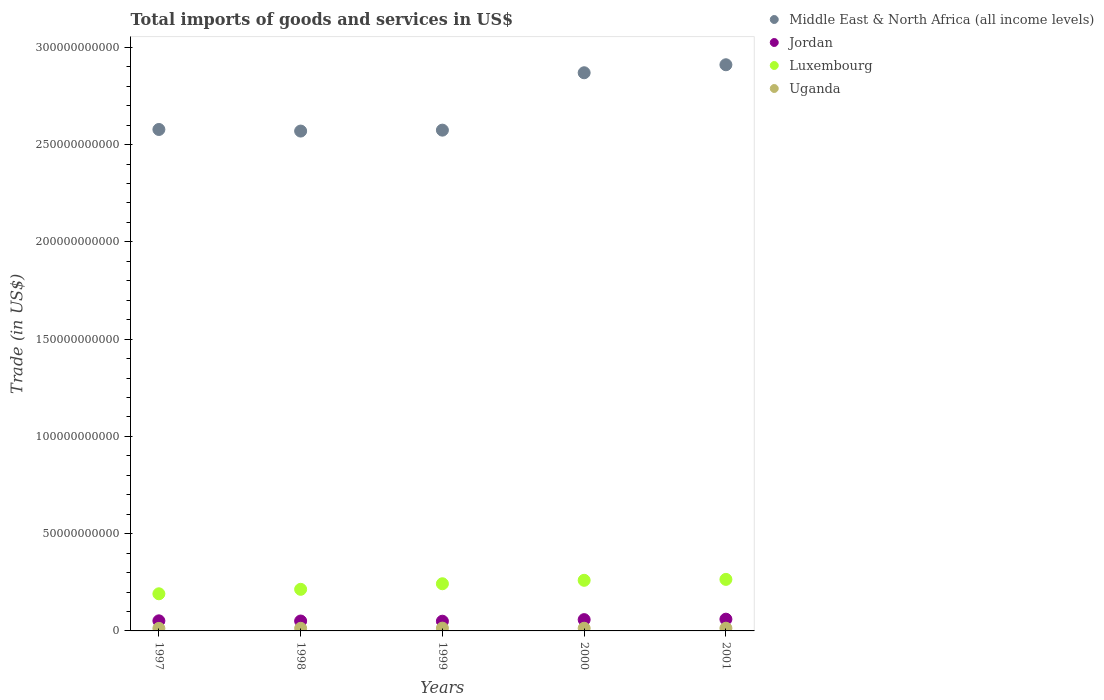What is the total imports of goods and services in Luxembourg in 1999?
Give a very brief answer. 2.42e+1. Across all years, what is the maximum total imports of goods and services in Middle East & North Africa (all income levels)?
Provide a succinct answer. 2.91e+11. Across all years, what is the minimum total imports of goods and services in Jordan?
Keep it short and to the point. 4.99e+09. In which year was the total imports of goods and services in Jordan maximum?
Provide a succinct answer. 2001. In which year was the total imports of goods and services in Jordan minimum?
Give a very brief answer. 1999. What is the total total imports of goods and services in Luxembourg in the graph?
Make the answer very short. 1.17e+11. What is the difference between the total imports of goods and services in Luxembourg in 1997 and that in 2001?
Provide a succinct answer. -7.41e+09. What is the difference between the total imports of goods and services in Middle East & North Africa (all income levels) in 1999 and the total imports of goods and services in Uganda in 2000?
Offer a very short reply. 2.56e+11. What is the average total imports of goods and services in Jordan per year?
Make the answer very short. 5.42e+09. In the year 1997, what is the difference between the total imports of goods and services in Middle East & North Africa (all income levels) and total imports of goods and services in Luxembourg?
Your answer should be very brief. 2.39e+11. In how many years, is the total imports of goods and services in Luxembourg greater than 60000000000 US$?
Your answer should be compact. 0. What is the ratio of the total imports of goods and services in Luxembourg in 1998 to that in 2000?
Ensure brevity in your answer.  0.82. Is the total imports of goods and services in Luxembourg in 1997 less than that in 2000?
Your answer should be very brief. Yes. Is the difference between the total imports of goods and services in Middle East & North Africa (all income levels) in 1997 and 2001 greater than the difference between the total imports of goods and services in Luxembourg in 1997 and 2001?
Make the answer very short. No. What is the difference between the highest and the second highest total imports of goods and services in Luxembourg?
Offer a terse response. 4.75e+08. What is the difference between the highest and the lowest total imports of goods and services in Middle East & North Africa (all income levels)?
Keep it short and to the point. 3.41e+1. In how many years, is the total imports of goods and services in Jordan greater than the average total imports of goods and services in Jordan taken over all years?
Keep it short and to the point. 2. Is it the case that in every year, the sum of the total imports of goods and services in Middle East & North Africa (all income levels) and total imports of goods and services in Luxembourg  is greater than the sum of total imports of goods and services in Jordan and total imports of goods and services in Uganda?
Offer a very short reply. Yes. Is it the case that in every year, the sum of the total imports of goods and services in Middle East & North Africa (all income levels) and total imports of goods and services in Luxembourg  is greater than the total imports of goods and services in Uganda?
Your response must be concise. Yes. Does the total imports of goods and services in Luxembourg monotonically increase over the years?
Provide a succinct answer. Yes. Is the total imports of goods and services in Luxembourg strictly less than the total imports of goods and services in Jordan over the years?
Your answer should be compact. No. How many dotlines are there?
Provide a short and direct response. 4. Does the graph contain any zero values?
Provide a succinct answer. No. Does the graph contain grids?
Your answer should be very brief. No. Where does the legend appear in the graph?
Give a very brief answer. Top right. How are the legend labels stacked?
Your answer should be compact. Vertical. What is the title of the graph?
Provide a succinct answer. Total imports of goods and services in US$. What is the label or title of the Y-axis?
Offer a terse response. Trade (in US$). What is the Trade (in US$) of Middle East & North Africa (all income levels) in 1997?
Make the answer very short. 2.58e+11. What is the Trade (in US$) in Jordan in 1997?
Make the answer very short. 5.19e+09. What is the Trade (in US$) of Luxembourg in 1997?
Give a very brief answer. 1.91e+1. What is the Trade (in US$) of Uganda in 1997?
Keep it short and to the point. 1.30e+09. What is the Trade (in US$) of Middle East & North Africa (all income levels) in 1998?
Your answer should be compact. 2.57e+11. What is the Trade (in US$) in Jordan in 1998?
Your answer should be compact. 5.09e+09. What is the Trade (in US$) of Luxembourg in 1998?
Your response must be concise. 2.14e+1. What is the Trade (in US$) of Uganda in 1998?
Offer a very short reply. 1.34e+09. What is the Trade (in US$) of Middle East & North Africa (all income levels) in 1999?
Provide a succinct answer. 2.57e+11. What is the Trade (in US$) in Jordan in 1999?
Give a very brief answer. 4.99e+09. What is the Trade (in US$) in Luxembourg in 1999?
Keep it short and to the point. 2.42e+1. What is the Trade (in US$) in Uganda in 1999?
Your response must be concise. 1.43e+09. What is the Trade (in US$) of Middle East & North Africa (all income levels) in 2000?
Give a very brief answer. 2.87e+11. What is the Trade (in US$) of Jordan in 2000?
Your answer should be compact. 5.80e+09. What is the Trade (in US$) of Luxembourg in 2000?
Give a very brief answer. 2.60e+1. What is the Trade (in US$) of Uganda in 2000?
Keep it short and to the point. 1.37e+09. What is the Trade (in US$) in Middle East & North Africa (all income levels) in 2001?
Ensure brevity in your answer.  2.91e+11. What is the Trade (in US$) of Jordan in 2001?
Your response must be concise. 6.03e+09. What is the Trade (in US$) in Luxembourg in 2001?
Provide a succinct answer. 2.65e+1. What is the Trade (in US$) of Uganda in 2001?
Offer a terse response. 1.39e+09. Across all years, what is the maximum Trade (in US$) of Middle East & North Africa (all income levels)?
Keep it short and to the point. 2.91e+11. Across all years, what is the maximum Trade (in US$) of Jordan?
Offer a very short reply. 6.03e+09. Across all years, what is the maximum Trade (in US$) in Luxembourg?
Your answer should be compact. 2.65e+1. Across all years, what is the maximum Trade (in US$) of Uganda?
Offer a terse response. 1.43e+09. Across all years, what is the minimum Trade (in US$) in Middle East & North Africa (all income levels)?
Make the answer very short. 2.57e+11. Across all years, what is the minimum Trade (in US$) of Jordan?
Your response must be concise. 4.99e+09. Across all years, what is the minimum Trade (in US$) in Luxembourg?
Provide a short and direct response. 1.91e+1. Across all years, what is the minimum Trade (in US$) in Uganda?
Your response must be concise. 1.30e+09. What is the total Trade (in US$) in Middle East & North Africa (all income levels) in the graph?
Provide a short and direct response. 1.35e+12. What is the total Trade (in US$) of Jordan in the graph?
Ensure brevity in your answer.  2.71e+1. What is the total Trade (in US$) of Luxembourg in the graph?
Provide a succinct answer. 1.17e+11. What is the total Trade (in US$) of Uganda in the graph?
Your answer should be compact. 6.83e+09. What is the difference between the Trade (in US$) of Middle East & North Africa (all income levels) in 1997 and that in 1998?
Make the answer very short. 8.19e+08. What is the difference between the Trade (in US$) in Jordan in 1997 and that in 1998?
Offer a very short reply. 9.59e+07. What is the difference between the Trade (in US$) in Luxembourg in 1997 and that in 1998?
Your answer should be very brief. -2.30e+09. What is the difference between the Trade (in US$) in Uganda in 1997 and that in 1998?
Your answer should be very brief. -3.97e+07. What is the difference between the Trade (in US$) of Middle East & North Africa (all income levels) in 1997 and that in 1999?
Offer a very short reply. 3.42e+08. What is the difference between the Trade (in US$) of Jordan in 1997 and that in 1999?
Your answer should be very brief. 1.96e+08. What is the difference between the Trade (in US$) in Luxembourg in 1997 and that in 1999?
Make the answer very short. -5.16e+09. What is the difference between the Trade (in US$) in Uganda in 1997 and that in 1999?
Offer a terse response. -1.22e+08. What is the difference between the Trade (in US$) of Middle East & North Africa (all income levels) in 1997 and that in 2000?
Keep it short and to the point. -2.92e+1. What is the difference between the Trade (in US$) of Jordan in 1997 and that in 2000?
Give a very brief answer. -6.16e+08. What is the difference between the Trade (in US$) in Luxembourg in 1997 and that in 2000?
Offer a very short reply. -6.93e+09. What is the difference between the Trade (in US$) in Uganda in 1997 and that in 2000?
Provide a short and direct response. -6.46e+07. What is the difference between the Trade (in US$) in Middle East & North Africa (all income levels) in 1997 and that in 2001?
Your answer should be compact. -3.33e+1. What is the difference between the Trade (in US$) in Jordan in 1997 and that in 2001?
Make the answer very short. -8.48e+08. What is the difference between the Trade (in US$) of Luxembourg in 1997 and that in 2001?
Provide a succinct answer. -7.41e+09. What is the difference between the Trade (in US$) of Uganda in 1997 and that in 2001?
Your response must be concise. -8.68e+07. What is the difference between the Trade (in US$) of Middle East & North Africa (all income levels) in 1998 and that in 1999?
Offer a terse response. -4.77e+08. What is the difference between the Trade (in US$) of Jordan in 1998 and that in 1999?
Provide a succinct answer. 9.99e+07. What is the difference between the Trade (in US$) in Luxembourg in 1998 and that in 1999?
Provide a succinct answer. -2.86e+09. What is the difference between the Trade (in US$) of Uganda in 1998 and that in 1999?
Give a very brief answer. -8.24e+07. What is the difference between the Trade (in US$) in Middle East & North Africa (all income levels) in 1998 and that in 2000?
Give a very brief answer. -3.00e+1. What is the difference between the Trade (in US$) of Jordan in 1998 and that in 2000?
Your response must be concise. -7.12e+08. What is the difference between the Trade (in US$) of Luxembourg in 1998 and that in 2000?
Offer a terse response. -4.63e+09. What is the difference between the Trade (in US$) of Uganda in 1998 and that in 2000?
Keep it short and to the point. -2.49e+07. What is the difference between the Trade (in US$) in Middle East & North Africa (all income levels) in 1998 and that in 2001?
Offer a terse response. -3.41e+1. What is the difference between the Trade (in US$) in Jordan in 1998 and that in 2001?
Provide a short and direct response. -9.44e+08. What is the difference between the Trade (in US$) in Luxembourg in 1998 and that in 2001?
Keep it short and to the point. -5.11e+09. What is the difference between the Trade (in US$) in Uganda in 1998 and that in 2001?
Provide a short and direct response. -4.71e+07. What is the difference between the Trade (in US$) of Middle East & North Africa (all income levels) in 1999 and that in 2000?
Keep it short and to the point. -2.95e+1. What is the difference between the Trade (in US$) of Jordan in 1999 and that in 2000?
Your answer should be compact. -8.12e+08. What is the difference between the Trade (in US$) of Luxembourg in 1999 and that in 2000?
Provide a short and direct response. -1.77e+09. What is the difference between the Trade (in US$) of Uganda in 1999 and that in 2000?
Offer a terse response. 5.75e+07. What is the difference between the Trade (in US$) of Middle East & North Africa (all income levels) in 1999 and that in 2001?
Your response must be concise. -3.36e+1. What is the difference between the Trade (in US$) in Jordan in 1999 and that in 2001?
Give a very brief answer. -1.04e+09. What is the difference between the Trade (in US$) in Luxembourg in 1999 and that in 2001?
Offer a very short reply. -2.24e+09. What is the difference between the Trade (in US$) in Uganda in 1999 and that in 2001?
Keep it short and to the point. 3.53e+07. What is the difference between the Trade (in US$) of Middle East & North Africa (all income levels) in 2000 and that in 2001?
Offer a terse response. -4.11e+09. What is the difference between the Trade (in US$) in Jordan in 2000 and that in 2001?
Your answer should be very brief. -2.32e+08. What is the difference between the Trade (in US$) in Luxembourg in 2000 and that in 2001?
Keep it short and to the point. -4.75e+08. What is the difference between the Trade (in US$) in Uganda in 2000 and that in 2001?
Provide a short and direct response. -2.22e+07. What is the difference between the Trade (in US$) of Middle East & North Africa (all income levels) in 1997 and the Trade (in US$) of Jordan in 1998?
Provide a succinct answer. 2.53e+11. What is the difference between the Trade (in US$) in Middle East & North Africa (all income levels) in 1997 and the Trade (in US$) in Luxembourg in 1998?
Offer a very short reply. 2.36e+11. What is the difference between the Trade (in US$) in Middle East & North Africa (all income levels) in 1997 and the Trade (in US$) in Uganda in 1998?
Your answer should be very brief. 2.56e+11. What is the difference between the Trade (in US$) in Jordan in 1997 and the Trade (in US$) in Luxembourg in 1998?
Provide a succinct answer. -1.62e+1. What is the difference between the Trade (in US$) in Jordan in 1997 and the Trade (in US$) in Uganda in 1998?
Offer a very short reply. 3.84e+09. What is the difference between the Trade (in US$) in Luxembourg in 1997 and the Trade (in US$) in Uganda in 1998?
Offer a very short reply. 1.77e+1. What is the difference between the Trade (in US$) in Middle East & North Africa (all income levels) in 1997 and the Trade (in US$) in Jordan in 1999?
Provide a short and direct response. 2.53e+11. What is the difference between the Trade (in US$) of Middle East & North Africa (all income levels) in 1997 and the Trade (in US$) of Luxembourg in 1999?
Provide a succinct answer. 2.34e+11. What is the difference between the Trade (in US$) of Middle East & North Africa (all income levels) in 1997 and the Trade (in US$) of Uganda in 1999?
Your answer should be very brief. 2.56e+11. What is the difference between the Trade (in US$) of Jordan in 1997 and the Trade (in US$) of Luxembourg in 1999?
Offer a terse response. -1.91e+1. What is the difference between the Trade (in US$) of Jordan in 1997 and the Trade (in US$) of Uganda in 1999?
Your answer should be compact. 3.76e+09. What is the difference between the Trade (in US$) in Luxembourg in 1997 and the Trade (in US$) in Uganda in 1999?
Offer a very short reply. 1.77e+1. What is the difference between the Trade (in US$) of Middle East & North Africa (all income levels) in 1997 and the Trade (in US$) of Jordan in 2000?
Offer a terse response. 2.52e+11. What is the difference between the Trade (in US$) of Middle East & North Africa (all income levels) in 1997 and the Trade (in US$) of Luxembourg in 2000?
Offer a very short reply. 2.32e+11. What is the difference between the Trade (in US$) in Middle East & North Africa (all income levels) in 1997 and the Trade (in US$) in Uganda in 2000?
Your answer should be very brief. 2.56e+11. What is the difference between the Trade (in US$) in Jordan in 1997 and the Trade (in US$) in Luxembourg in 2000?
Your answer should be compact. -2.08e+1. What is the difference between the Trade (in US$) in Jordan in 1997 and the Trade (in US$) in Uganda in 2000?
Provide a short and direct response. 3.82e+09. What is the difference between the Trade (in US$) of Luxembourg in 1997 and the Trade (in US$) of Uganda in 2000?
Keep it short and to the point. 1.77e+1. What is the difference between the Trade (in US$) in Middle East & North Africa (all income levels) in 1997 and the Trade (in US$) in Jordan in 2001?
Offer a very short reply. 2.52e+11. What is the difference between the Trade (in US$) in Middle East & North Africa (all income levels) in 1997 and the Trade (in US$) in Luxembourg in 2001?
Give a very brief answer. 2.31e+11. What is the difference between the Trade (in US$) of Middle East & North Africa (all income levels) in 1997 and the Trade (in US$) of Uganda in 2001?
Provide a short and direct response. 2.56e+11. What is the difference between the Trade (in US$) of Jordan in 1997 and the Trade (in US$) of Luxembourg in 2001?
Your response must be concise. -2.13e+1. What is the difference between the Trade (in US$) in Jordan in 1997 and the Trade (in US$) in Uganda in 2001?
Your answer should be very brief. 3.80e+09. What is the difference between the Trade (in US$) of Luxembourg in 1997 and the Trade (in US$) of Uganda in 2001?
Ensure brevity in your answer.  1.77e+1. What is the difference between the Trade (in US$) in Middle East & North Africa (all income levels) in 1998 and the Trade (in US$) in Jordan in 1999?
Offer a terse response. 2.52e+11. What is the difference between the Trade (in US$) of Middle East & North Africa (all income levels) in 1998 and the Trade (in US$) of Luxembourg in 1999?
Provide a short and direct response. 2.33e+11. What is the difference between the Trade (in US$) in Middle East & North Africa (all income levels) in 1998 and the Trade (in US$) in Uganda in 1999?
Make the answer very short. 2.56e+11. What is the difference between the Trade (in US$) in Jordan in 1998 and the Trade (in US$) in Luxembourg in 1999?
Offer a very short reply. -1.92e+1. What is the difference between the Trade (in US$) of Jordan in 1998 and the Trade (in US$) of Uganda in 1999?
Keep it short and to the point. 3.66e+09. What is the difference between the Trade (in US$) of Luxembourg in 1998 and the Trade (in US$) of Uganda in 1999?
Ensure brevity in your answer.  2.00e+1. What is the difference between the Trade (in US$) of Middle East & North Africa (all income levels) in 1998 and the Trade (in US$) of Jordan in 2000?
Offer a terse response. 2.51e+11. What is the difference between the Trade (in US$) in Middle East & North Africa (all income levels) in 1998 and the Trade (in US$) in Luxembourg in 2000?
Make the answer very short. 2.31e+11. What is the difference between the Trade (in US$) in Middle East & North Africa (all income levels) in 1998 and the Trade (in US$) in Uganda in 2000?
Your answer should be very brief. 2.56e+11. What is the difference between the Trade (in US$) of Jordan in 1998 and the Trade (in US$) of Luxembourg in 2000?
Your response must be concise. -2.09e+1. What is the difference between the Trade (in US$) in Jordan in 1998 and the Trade (in US$) in Uganda in 2000?
Your answer should be very brief. 3.72e+09. What is the difference between the Trade (in US$) of Luxembourg in 1998 and the Trade (in US$) of Uganda in 2000?
Provide a short and direct response. 2.00e+1. What is the difference between the Trade (in US$) in Middle East & North Africa (all income levels) in 1998 and the Trade (in US$) in Jordan in 2001?
Make the answer very short. 2.51e+11. What is the difference between the Trade (in US$) of Middle East & North Africa (all income levels) in 1998 and the Trade (in US$) of Luxembourg in 2001?
Give a very brief answer. 2.30e+11. What is the difference between the Trade (in US$) of Middle East & North Africa (all income levels) in 1998 and the Trade (in US$) of Uganda in 2001?
Provide a succinct answer. 2.56e+11. What is the difference between the Trade (in US$) of Jordan in 1998 and the Trade (in US$) of Luxembourg in 2001?
Give a very brief answer. -2.14e+1. What is the difference between the Trade (in US$) in Jordan in 1998 and the Trade (in US$) in Uganda in 2001?
Give a very brief answer. 3.70e+09. What is the difference between the Trade (in US$) of Luxembourg in 1998 and the Trade (in US$) of Uganda in 2001?
Offer a very short reply. 2.00e+1. What is the difference between the Trade (in US$) of Middle East & North Africa (all income levels) in 1999 and the Trade (in US$) of Jordan in 2000?
Give a very brief answer. 2.52e+11. What is the difference between the Trade (in US$) in Middle East & North Africa (all income levels) in 1999 and the Trade (in US$) in Luxembourg in 2000?
Give a very brief answer. 2.31e+11. What is the difference between the Trade (in US$) in Middle East & North Africa (all income levels) in 1999 and the Trade (in US$) in Uganda in 2000?
Give a very brief answer. 2.56e+11. What is the difference between the Trade (in US$) of Jordan in 1999 and the Trade (in US$) of Luxembourg in 2000?
Ensure brevity in your answer.  -2.10e+1. What is the difference between the Trade (in US$) in Jordan in 1999 and the Trade (in US$) in Uganda in 2000?
Make the answer very short. 3.62e+09. What is the difference between the Trade (in US$) in Luxembourg in 1999 and the Trade (in US$) in Uganda in 2000?
Make the answer very short. 2.29e+1. What is the difference between the Trade (in US$) in Middle East & North Africa (all income levels) in 1999 and the Trade (in US$) in Jordan in 2001?
Make the answer very short. 2.51e+11. What is the difference between the Trade (in US$) in Middle East & North Africa (all income levels) in 1999 and the Trade (in US$) in Luxembourg in 2001?
Your response must be concise. 2.31e+11. What is the difference between the Trade (in US$) of Middle East & North Africa (all income levels) in 1999 and the Trade (in US$) of Uganda in 2001?
Offer a terse response. 2.56e+11. What is the difference between the Trade (in US$) in Jordan in 1999 and the Trade (in US$) in Luxembourg in 2001?
Offer a terse response. -2.15e+1. What is the difference between the Trade (in US$) in Jordan in 1999 and the Trade (in US$) in Uganda in 2001?
Give a very brief answer. 3.60e+09. What is the difference between the Trade (in US$) of Luxembourg in 1999 and the Trade (in US$) of Uganda in 2001?
Give a very brief answer. 2.29e+1. What is the difference between the Trade (in US$) of Middle East & North Africa (all income levels) in 2000 and the Trade (in US$) of Jordan in 2001?
Your response must be concise. 2.81e+11. What is the difference between the Trade (in US$) in Middle East & North Africa (all income levels) in 2000 and the Trade (in US$) in Luxembourg in 2001?
Your response must be concise. 2.60e+11. What is the difference between the Trade (in US$) of Middle East & North Africa (all income levels) in 2000 and the Trade (in US$) of Uganda in 2001?
Offer a terse response. 2.86e+11. What is the difference between the Trade (in US$) of Jordan in 2000 and the Trade (in US$) of Luxembourg in 2001?
Your answer should be very brief. -2.07e+1. What is the difference between the Trade (in US$) of Jordan in 2000 and the Trade (in US$) of Uganda in 2001?
Your answer should be very brief. 4.41e+09. What is the difference between the Trade (in US$) in Luxembourg in 2000 and the Trade (in US$) in Uganda in 2001?
Ensure brevity in your answer.  2.46e+1. What is the average Trade (in US$) of Middle East & North Africa (all income levels) per year?
Your answer should be compact. 2.70e+11. What is the average Trade (in US$) of Jordan per year?
Ensure brevity in your answer.  5.42e+09. What is the average Trade (in US$) in Luxembourg per year?
Provide a short and direct response. 2.34e+1. What is the average Trade (in US$) of Uganda per year?
Give a very brief answer. 1.37e+09. In the year 1997, what is the difference between the Trade (in US$) of Middle East & North Africa (all income levels) and Trade (in US$) of Jordan?
Offer a very short reply. 2.53e+11. In the year 1997, what is the difference between the Trade (in US$) in Middle East & North Africa (all income levels) and Trade (in US$) in Luxembourg?
Your answer should be compact. 2.39e+11. In the year 1997, what is the difference between the Trade (in US$) in Middle East & North Africa (all income levels) and Trade (in US$) in Uganda?
Your answer should be very brief. 2.56e+11. In the year 1997, what is the difference between the Trade (in US$) in Jordan and Trade (in US$) in Luxembourg?
Ensure brevity in your answer.  -1.39e+1. In the year 1997, what is the difference between the Trade (in US$) in Jordan and Trade (in US$) in Uganda?
Give a very brief answer. 3.88e+09. In the year 1997, what is the difference between the Trade (in US$) of Luxembourg and Trade (in US$) of Uganda?
Provide a succinct answer. 1.78e+1. In the year 1998, what is the difference between the Trade (in US$) in Middle East & North Africa (all income levels) and Trade (in US$) in Jordan?
Ensure brevity in your answer.  2.52e+11. In the year 1998, what is the difference between the Trade (in US$) of Middle East & North Africa (all income levels) and Trade (in US$) of Luxembourg?
Offer a terse response. 2.36e+11. In the year 1998, what is the difference between the Trade (in US$) of Middle East & North Africa (all income levels) and Trade (in US$) of Uganda?
Provide a succinct answer. 2.56e+11. In the year 1998, what is the difference between the Trade (in US$) of Jordan and Trade (in US$) of Luxembourg?
Your answer should be very brief. -1.63e+1. In the year 1998, what is the difference between the Trade (in US$) of Jordan and Trade (in US$) of Uganda?
Ensure brevity in your answer.  3.75e+09. In the year 1998, what is the difference between the Trade (in US$) of Luxembourg and Trade (in US$) of Uganda?
Provide a succinct answer. 2.00e+1. In the year 1999, what is the difference between the Trade (in US$) in Middle East & North Africa (all income levels) and Trade (in US$) in Jordan?
Give a very brief answer. 2.52e+11. In the year 1999, what is the difference between the Trade (in US$) of Middle East & North Africa (all income levels) and Trade (in US$) of Luxembourg?
Keep it short and to the point. 2.33e+11. In the year 1999, what is the difference between the Trade (in US$) in Middle East & North Africa (all income levels) and Trade (in US$) in Uganda?
Provide a succinct answer. 2.56e+11. In the year 1999, what is the difference between the Trade (in US$) of Jordan and Trade (in US$) of Luxembourg?
Provide a succinct answer. -1.93e+1. In the year 1999, what is the difference between the Trade (in US$) in Jordan and Trade (in US$) in Uganda?
Provide a short and direct response. 3.56e+09. In the year 1999, what is the difference between the Trade (in US$) in Luxembourg and Trade (in US$) in Uganda?
Give a very brief answer. 2.28e+1. In the year 2000, what is the difference between the Trade (in US$) in Middle East & North Africa (all income levels) and Trade (in US$) in Jordan?
Provide a succinct answer. 2.81e+11. In the year 2000, what is the difference between the Trade (in US$) of Middle East & North Africa (all income levels) and Trade (in US$) of Luxembourg?
Your answer should be compact. 2.61e+11. In the year 2000, what is the difference between the Trade (in US$) in Middle East & North Africa (all income levels) and Trade (in US$) in Uganda?
Give a very brief answer. 2.86e+11. In the year 2000, what is the difference between the Trade (in US$) in Jordan and Trade (in US$) in Luxembourg?
Your answer should be very brief. -2.02e+1. In the year 2000, what is the difference between the Trade (in US$) of Jordan and Trade (in US$) of Uganda?
Offer a terse response. 4.43e+09. In the year 2000, what is the difference between the Trade (in US$) in Luxembourg and Trade (in US$) in Uganda?
Your answer should be compact. 2.46e+1. In the year 2001, what is the difference between the Trade (in US$) of Middle East & North Africa (all income levels) and Trade (in US$) of Jordan?
Offer a terse response. 2.85e+11. In the year 2001, what is the difference between the Trade (in US$) of Middle East & North Africa (all income levels) and Trade (in US$) of Luxembourg?
Provide a short and direct response. 2.65e+11. In the year 2001, what is the difference between the Trade (in US$) in Middle East & North Africa (all income levels) and Trade (in US$) in Uganda?
Provide a short and direct response. 2.90e+11. In the year 2001, what is the difference between the Trade (in US$) of Jordan and Trade (in US$) of Luxembourg?
Ensure brevity in your answer.  -2.05e+1. In the year 2001, what is the difference between the Trade (in US$) in Jordan and Trade (in US$) in Uganda?
Your answer should be compact. 4.64e+09. In the year 2001, what is the difference between the Trade (in US$) of Luxembourg and Trade (in US$) of Uganda?
Offer a terse response. 2.51e+1. What is the ratio of the Trade (in US$) in Jordan in 1997 to that in 1998?
Keep it short and to the point. 1.02. What is the ratio of the Trade (in US$) of Luxembourg in 1997 to that in 1998?
Provide a short and direct response. 0.89. What is the ratio of the Trade (in US$) of Uganda in 1997 to that in 1998?
Make the answer very short. 0.97. What is the ratio of the Trade (in US$) in Middle East & North Africa (all income levels) in 1997 to that in 1999?
Offer a terse response. 1. What is the ratio of the Trade (in US$) in Jordan in 1997 to that in 1999?
Your answer should be compact. 1.04. What is the ratio of the Trade (in US$) of Luxembourg in 1997 to that in 1999?
Your response must be concise. 0.79. What is the ratio of the Trade (in US$) of Uganda in 1997 to that in 1999?
Provide a succinct answer. 0.91. What is the ratio of the Trade (in US$) in Middle East & North Africa (all income levels) in 1997 to that in 2000?
Give a very brief answer. 0.9. What is the ratio of the Trade (in US$) in Jordan in 1997 to that in 2000?
Provide a succinct answer. 0.89. What is the ratio of the Trade (in US$) in Luxembourg in 1997 to that in 2000?
Offer a terse response. 0.73. What is the ratio of the Trade (in US$) in Uganda in 1997 to that in 2000?
Your answer should be very brief. 0.95. What is the ratio of the Trade (in US$) of Middle East & North Africa (all income levels) in 1997 to that in 2001?
Offer a terse response. 0.89. What is the ratio of the Trade (in US$) of Jordan in 1997 to that in 2001?
Your answer should be compact. 0.86. What is the ratio of the Trade (in US$) of Luxembourg in 1997 to that in 2001?
Keep it short and to the point. 0.72. What is the ratio of the Trade (in US$) in Uganda in 1997 to that in 2001?
Your answer should be compact. 0.94. What is the ratio of the Trade (in US$) of Middle East & North Africa (all income levels) in 1998 to that in 1999?
Your answer should be very brief. 1. What is the ratio of the Trade (in US$) of Luxembourg in 1998 to that in 1999?
Give a very brief answer. 0.88. What is the ratio of the Trade (in US$) in Uganda in 1998 to that in 1999?
Your response must be concise. 0.94. What is the ratio of the Trade (in US$) in Middle East & North Africa (all income levels) in 1998 to that in 2000?
Give a very brief answer. 0.9. What is the ratio of the Trade (in US$) in Jordan in 1998 to that in 2000?
Offer a very short reply. 0.88. What is the ratio of the Trade (in US$) in Luxembourg in 1998 to that in 2000?
Your answer should be compact. 0.82. What is the ratio of the Trade (in US$) in Uganda in 1998 to that in 2000?
Your response must be concise. 0.98. What is the ratio of the Trade (in US$) in Middle East & North Africa (all income levels) in 1998 to that in 2001?
Provide a short and direct response. 0.88. What is the ratio of the Trade (in US$) in Jordan in 1998 to that in 2001?
Offer a very short reply. 0.84. What is the ratio of the Trade (in US$) of Luxembourg in 1998 to that in 2001?
Keep it short and to the point. 0.81. What is the ratio of the Trade (in US$) in Uganda in 1998 to that in 2001?
Ensure brevity in your answer.  0.97. What is the ratio of the Trade (in US$) in Middle East & North Africa (all income levels) in 1999 to that in 2000?
Provide a succinct answer. 0.9. What is the ratio of the Trade (in US$) in Jordan in 1999 to that in 2000?
Your response must be concise. 0.86. What is the ratio of the Trade (in US$) in Luxembourg in 1999 to that in 2000?
Your answer should be very brief. 0.93. What is the ratio of the Trade (in US$) in Uganda in 1999 to that in 2000?
Offer a very short reply. 1.04. What is the ratio of the Trade (in US$) in Middle East & North Africa (all income levels) in 1999 to that in 2001?
Give a very brief answer. 0.88. What is the ratio of the Trade (in US$) in Jordan in 1999 to that in 2001?
Make the answer very short. 0.83. What is the ratio of the Trade (in US$) of Luxembourg in 1999 to that in 2001?
Keep it short and to the point. 0.92. What is the ratio of the Trade (in US$) in Uganda in 1999 to that in 2001?
Your response must be concise. 1.03. What is the ratio of the Trade (in US$) in Middle East & North Africa (all income levels) in 2000 to that in 2001?
Offer a very short reply. 0.99. What is the ratio of the Trade (in US$) of Jordan in 2000 to that in 2001?
Your answer should be very brief. 0.96. What is the ratio of the Trade (in US$) of Luxembourg in 2000 to that in 2001?
Give a very brief answer. 0.98. What is the ratio of the Trade (in US$) of Uganda in 2000 to that in 2001?
Make the answer very short. 0.98. What is the difference between the highest and the second highest Trade (in US$) of Middle East & North Africa (all income levels)?
Give a very brief answer. 4.11e+09. What is the difference between the highest and the second highest Trade (in US$) in Jordan?
Keep it short and to the point. 2.32e+08. What is the difference between the highest and the second highest Trade (in US$) of Luxembourg?
Keep it short and to the point. 4.75e+08. What is the difference between the highest and the second highest Trade (in US$) in Uganda?
Your response must be concise. 3.53e+07. What is the difference between the highest and the lowest Trade (in US$) in Middle East & North Africa (all income levels)?
Your answer should be compact. 3.41e+1. What is the difference between the highest and the lowest Trade (in US$) in Jordan?
Your response must be concise. 1.04e+09. What is the difference between the highest and the lowest Trade (in US$) of Luxembourg?
Your response must be concise. 7.41e+09. What is the difference between the highest and the lowest Trade (in US$) in Uganda?
Provide a succinct answer. 1.22e+08. 